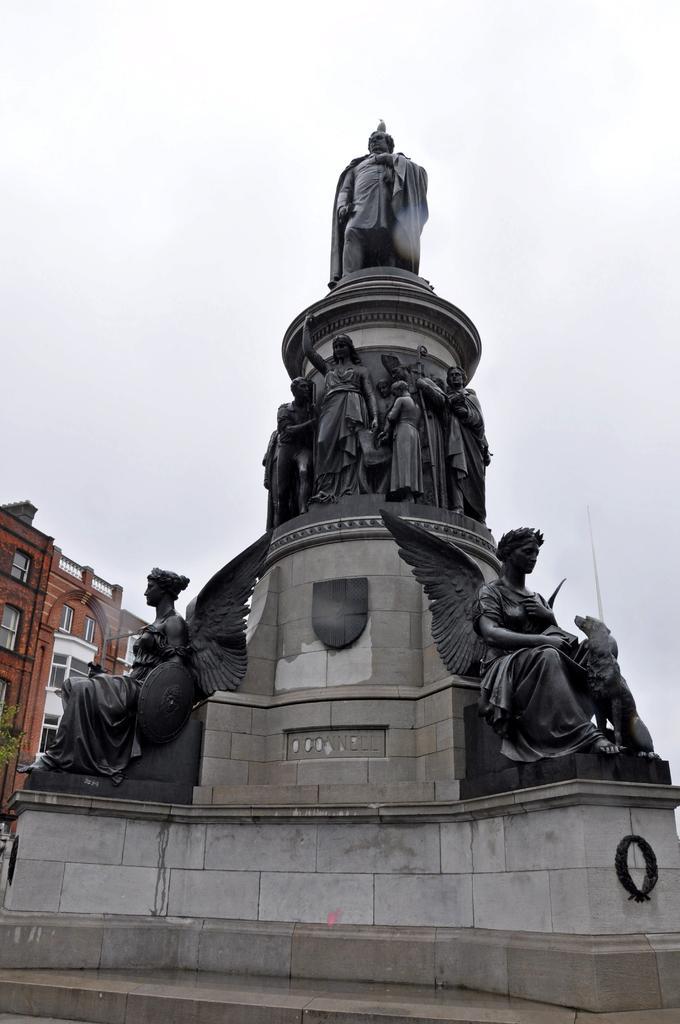Please provide a concise description of this image. In this image I can see number of sculptures and red colour building in background. 